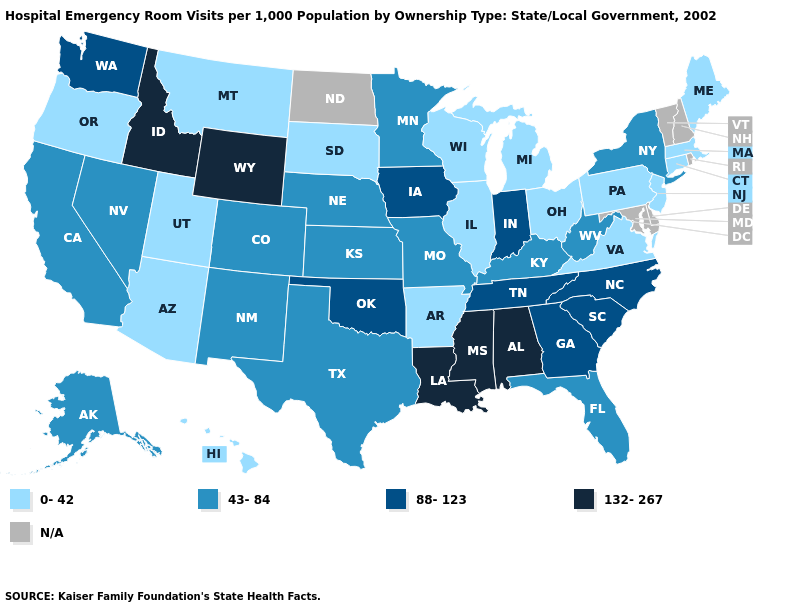Name the states that have a value in the range 88-123?
Write a very short answer. Georgia, Indiana, Iowa, North Carolina, Oklahoma, South Carolina, Tennessee, Washington. Name the states that have a value in the range 132-267?
Quick response, please. Alabama, Idaho, Louisiana, Mississippi, Wyoming. Which states hav the highest value in the Northeast?
Short answer required. New York. Name the states that have a value in the range 0-42?
Keep it brief. Arizona, Arkansas, Connecticut, Hawaii, Illinois, Maine, Massachusetts, Michigan, Montana, New Jersey, Ohio, Oregon, Pennsylvania, South Dakota, Utah, Virginia, Wisconsin. What is the value of North Dakota?
Quick response, please. N/A. Which states have the highest value in the USA?
Short answer required. Alabama, Idaho, Louisiana, Mississippi, Wyoming. Which states have the lowest value in the West?
Quick response, please. Arizona, Hawaii, Montana, Oregon, Utah. Which states have the lowest value in the USA?
Give a very brief answer. Arizona, Arkansas, Connecticut, Hawaii, Illinois, Maine, Massachusetts, Michigan, Montana, New Jersey, Ohio, Oregon, Pennsylvania, South Dakota, Utah, Virginia, Wisconsin. Does New York have the highest value in the Northeast?
Quick response, please. Yes. How many symbols are there in the legend?
Keep it brief. 5. Name the states that have a value in the range 132-267?
Keep it brief. Alabama, Idaho, Louisiana, Mississippi, Wyoming. What is the lowest value in states that border Minnesota?
Be succinct. 0-42. Name the states that have a value in the range 88-123?
Keep it brief. Georgia, Indiana, Iowa, North Carolina, Oklahoma, South Carolina, Tennessee, Washington. What is the value of Indiana?
Answer briefly. 88-123. 